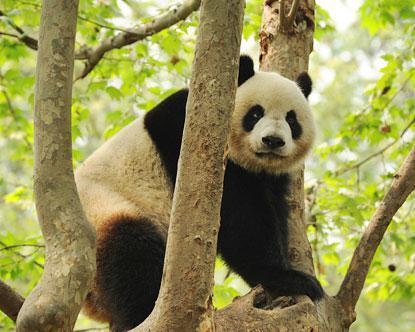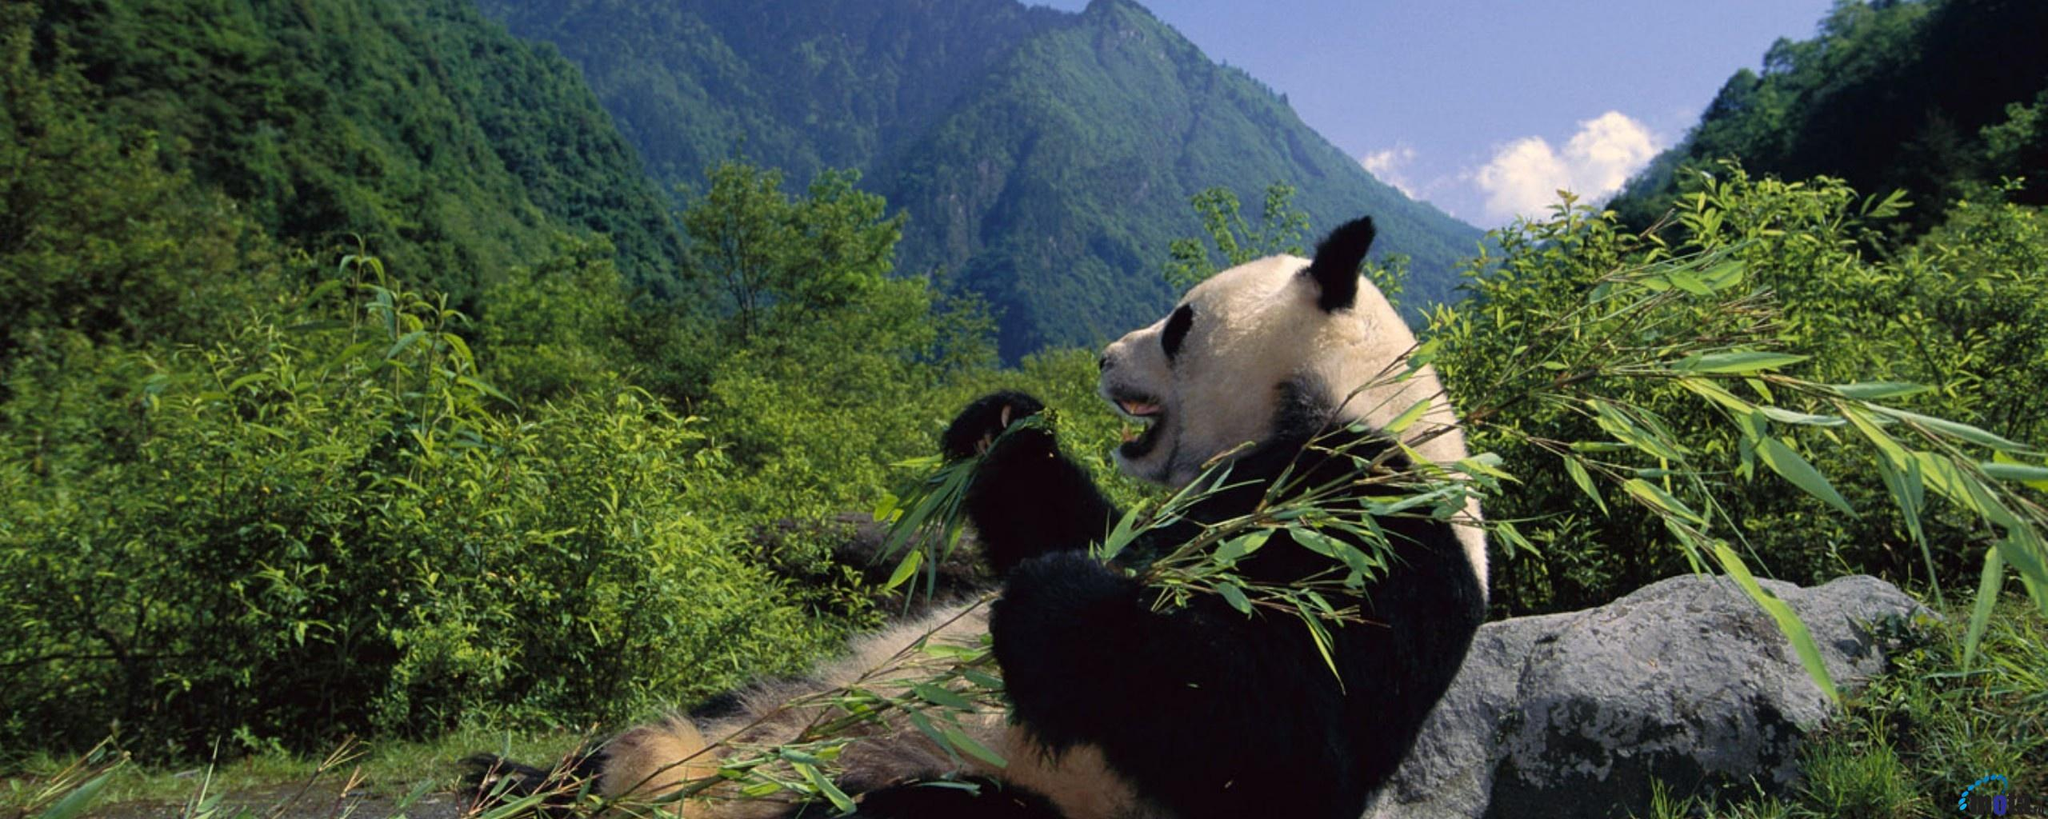The first image is the image on the left, the second image is the image on the right. For the images displayed, is the sentence "Each image features a panda in a tree" factually correct? Answer yes or no. No. 